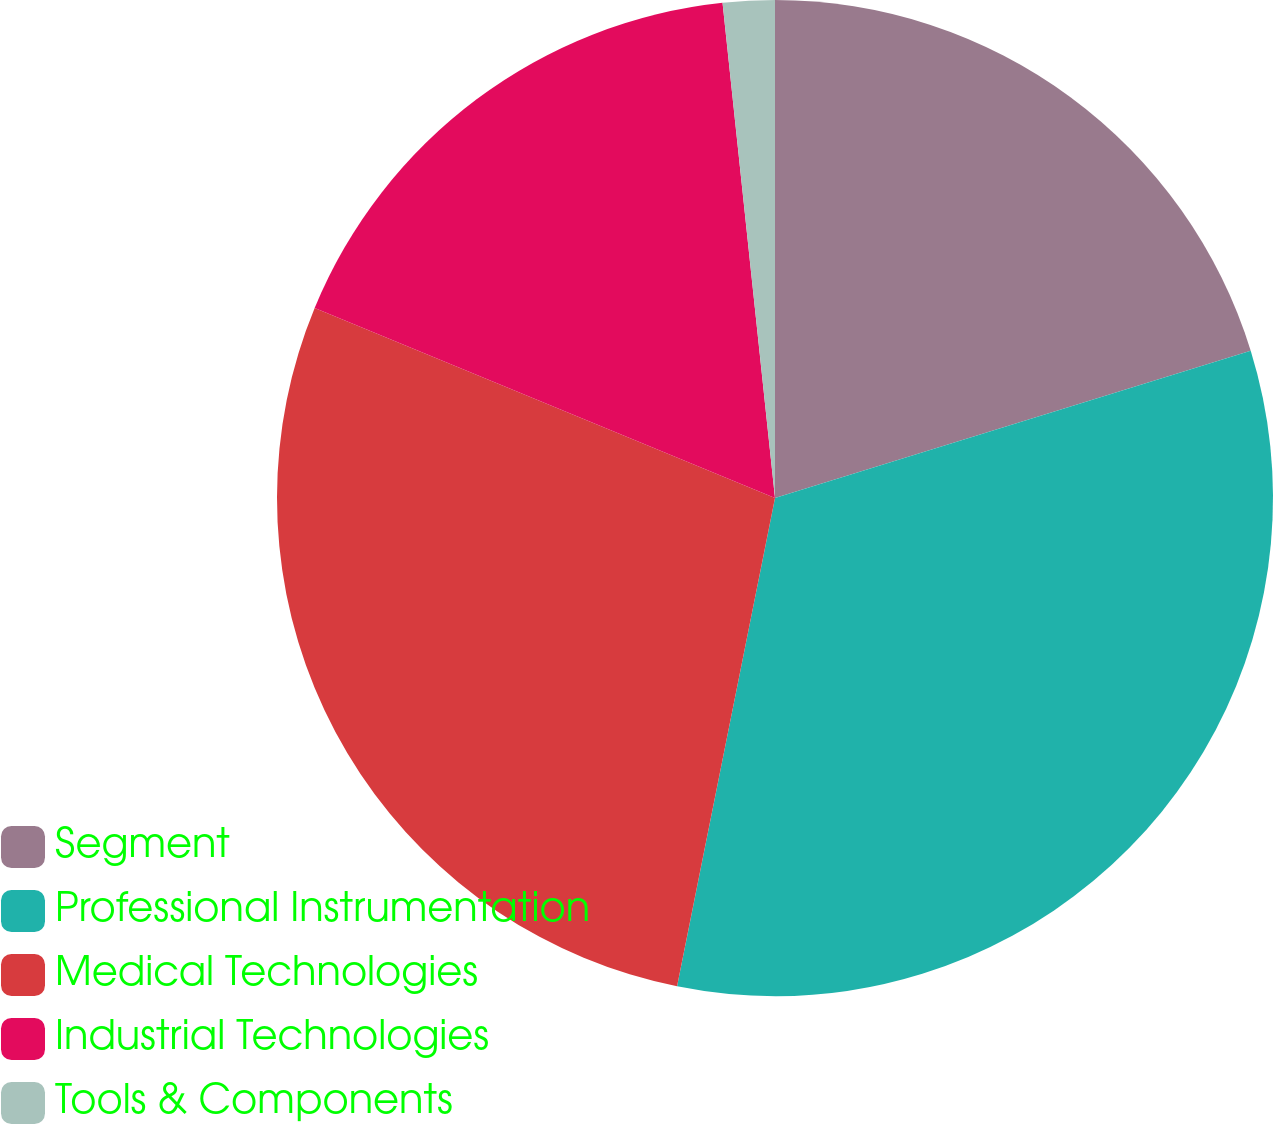Convert chart. <chart><loc_0><loc_0><loc_500><loc_500><pie_chart><fcel>Segment<fcel>Professional Instrumentation<fcel>Medical Technologies<fcel>Industrial Technologies<fcel>Tools & Components<nl><fcel>20.22%<fcel>32.93%<fcel>28.08%<fcel>17.09%<fcel>1.68%<nl></chart> 